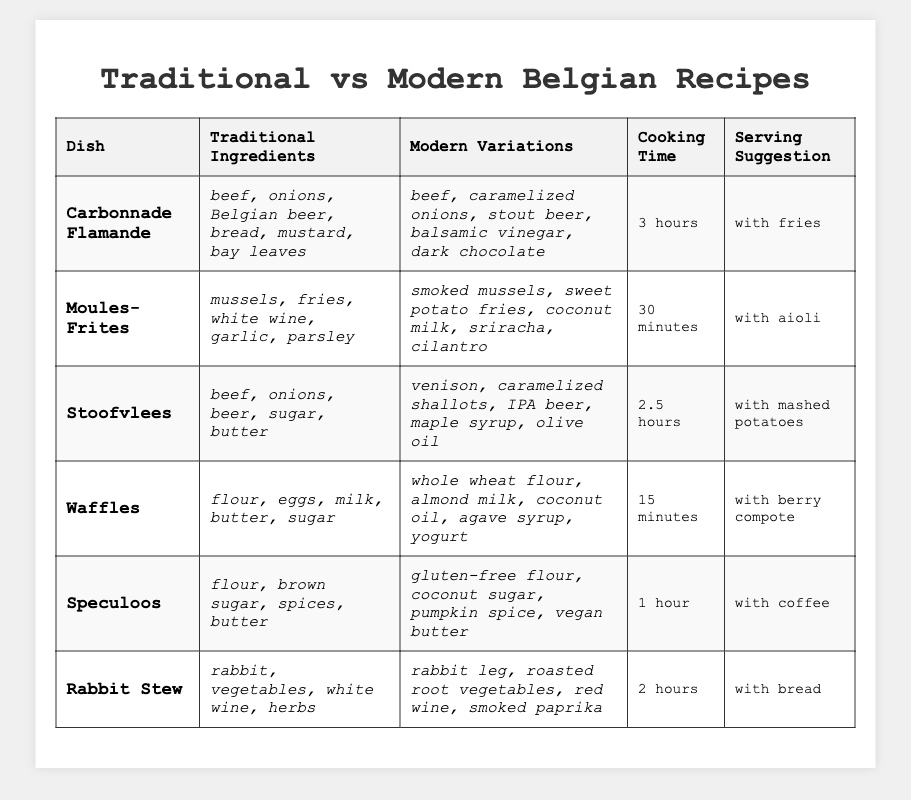What is the cooking time for Carbonnade Flamande? The table states that the cooking time for Carbonnade Flamande is listed in the designated cooking time column. It specifically mentions "3 hours."
Answer: 3 hours Which dish has the shortest cooking time? By examining the cooking time column, it is evident that Waffles has the shortest cooking time at "15 minutes," compared to the other dishes which take longer.
Answer: Waffles Does Rabbit Stew use red wine in its traditional recipe? The table lists the traditional ingredients for Rabbit Stew, which are rabbit, vegetables, white wine, and herbs. Red wine is not mentioned among these ingredients.
Answer: No What is the modern variation for Speculoos? The table indicates modern variations for Speculoos as gluten-free flour, coconut sugar, pumpkin spice, and vegan butter.
Answer: Gluten-free flour, coconut sugar, pumpkin spice, vegan butter Which dish has the longest cooking time, and by how much longer is it than Stoofvlees? The longest cooking time is for Carbonnade Flamande at "3 hours." Stoofvlees has a cooking time of "2.5 hours," meaning Carbonnade Flamande takes 30 minutes longer than Stoofvlees.
Answer: Carbonnade Flamande, 30 minutes longer What are the traditional ingredients for Moules-Frites? The table shows that the traditional ingredients for Moules-Frites are mussels, fries, white wine, garlic, and parsley.
Answer: Mussels, fries, white wine, garlic, parsley How many dishes suggest serving with fries? By checking the serving suggestions column, both Carbonnade Flamande and Moules-Frites suggest serving with fries, totaling two dishes.
Answer: 2 dishes Are there any dishes featuring beef in their traditional recipes? Carbonnade Flamande and Stoofvlees both feature beef in their traditional recipes, so the answer is yes.
Answer: Yes What is the difference in cooking time between Waffles and Rabbit Stew? The cooking time for Waffles is "15 minutes," while for Rabbit Stew it is "2 hours." Converting "2 hours" to minutes gives 120 minutes. The difference is 120 - 15 = 105 minutes.
Answer: 105 minutes Which modern variation for Stoofvlees replaces beef? The modern variation for Stoofvlees replaces beef with venison, as stated in the modern variations column of the table.
Answer: Venison What is the serving suggestion for Waffles? The table lists the serving suggestion for Waffles as "with berry compote," which directly answers the question.
Answer: With berry compote 